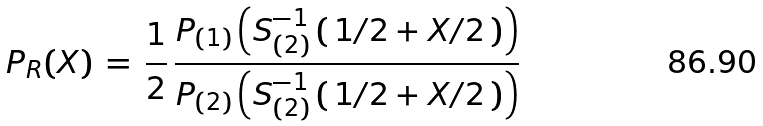<formula> <loc_0><loc_0><loc_500><loc_500>P _ { R } ( X ) \, = \, \frac { 1 } { 2 } \, \frac { P _ { ( 1 ) } \left ( S _ { ( 2 ) } ^ { - 1 } \, ( \, 1 / 2 + X / 2 \, ) \right ) } { P _ { ( 2 ) } \left ( S _ { ( 2 ) } ^ { - 1 } \, ( \, 1 / 2 + X / 2 \, ) \right ) }</formula> 